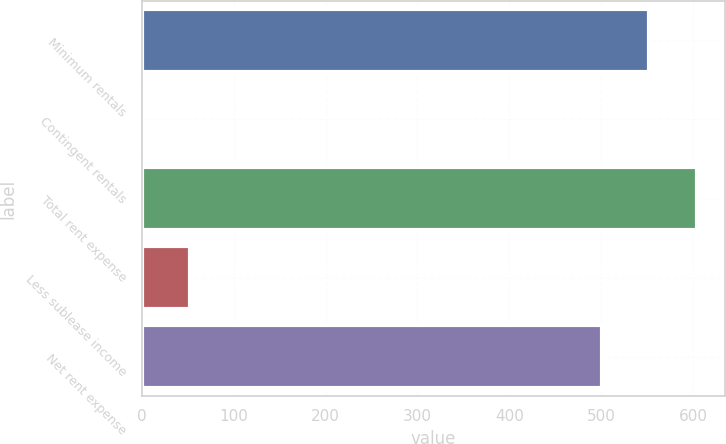<chart> <loc_0><loc_0><loc_500><loc_500><bar_chart><fcel>Minimum rentals<fcel>Contingent rentals<fcel>Total rent expense<fcel>Less sublease income<fcel>Net rent expense<nl><fcel>552.6<fcel>1<fcel>604.2<fcel>52.6<fcel>501<nl></chart> 